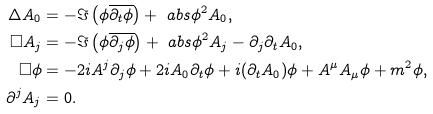<formula> <loc_0><loc_0><loc_500><loc_500>\Delta A _ { 0 } & = - \Im \left ( \phi \overline { \partial _ { t } \phi } \right ) + \ a b s { \phi } ^ { 2 } A _ { 0 } , \\ \square A _ { j } & = - \Im \left ( \phi \overline { \partial _ { j } \phi } \right ) + \ a b s { \phi } ^ { 2 } A _ { j } - \partial _ { j } \partial _ { t } A _ { 0 } , \\ \square \phi & = - 2 i A ^ { j } \partial _ { j } \phi + 2 i A _ { 0 } \partial _ { t } \phi + i ( \partial _ { t } A _ { 0 } ) \phi + A ^ { \mu } A _ { \mu } \phi + m ^ { 2 } \phi , \\ \partial ^ { j } A _ { j } & = 0 .</formula> 